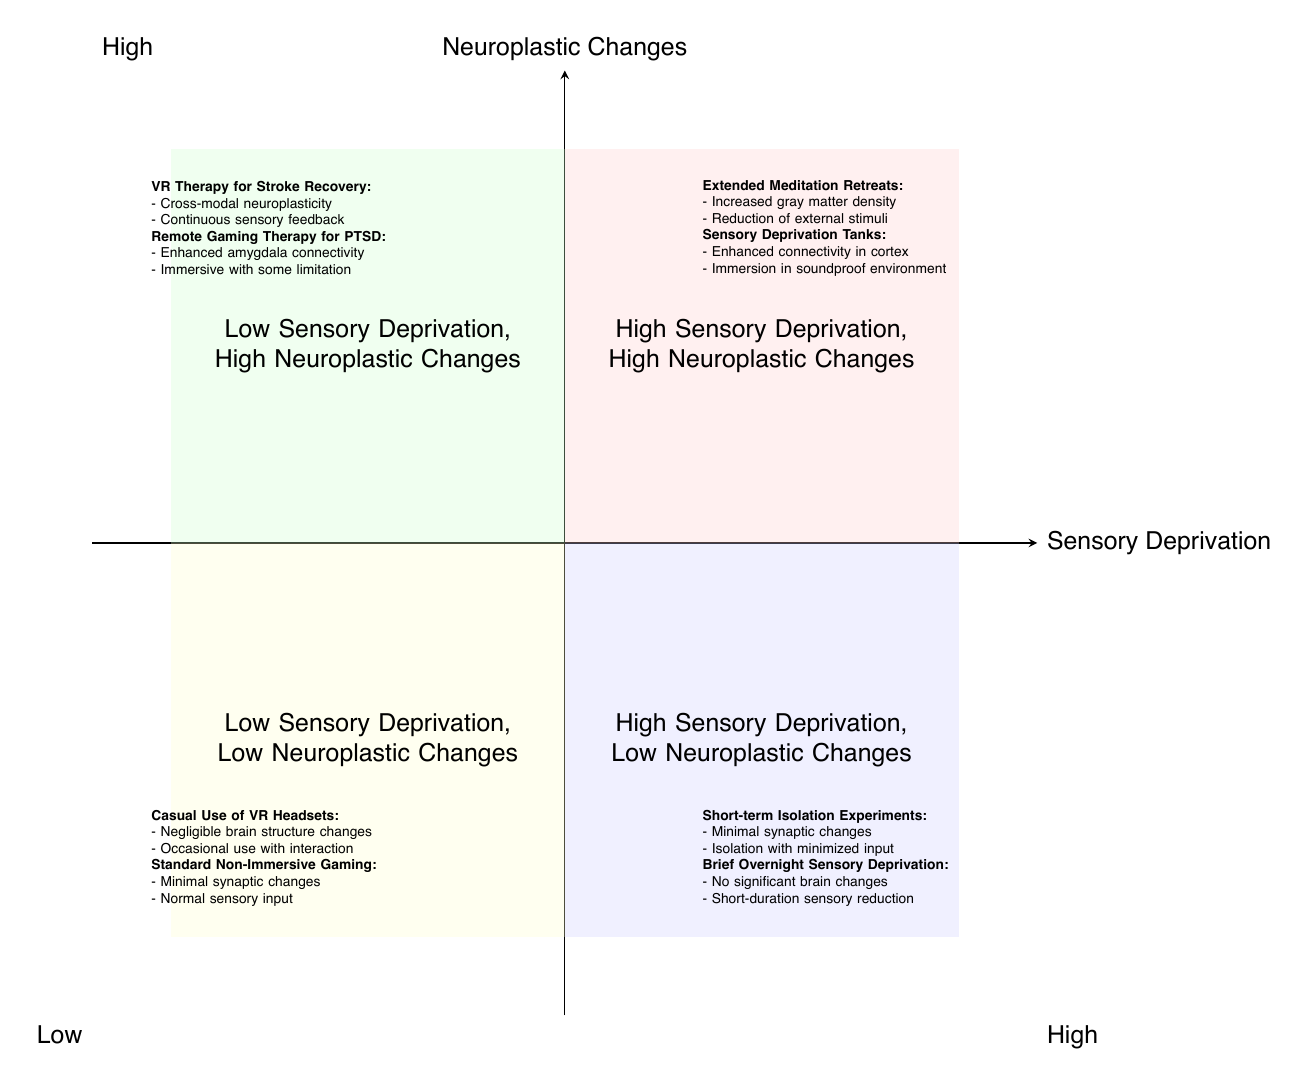What are the two case studies listed in the quadrant for High Sensory Deprivation, High Neuroplastic Changes? The quadrant for High Sensory Deprivation, High Neuroplastic Changes lists "Extended Meditation Retreats" and "Sensory Deprivation Tanks" as its two case studies.
Answer: Extended Meditation Retreats, Sensory Deprivation Tanks Which quadrant is associated with Minimal synaptic changes observed? The quadrant associated with "Minimal synaptic changes observed" is "High Sensory Deprivation, Low Neuroplastic Changes," which includes the case study "Short-term Isolation Experiments."
Answer: High Sensory Deprivation, Low Neuroplastic Changes How many examples are provided for the quadrant "Low Sensory Deprivation, High Neuroplastic Changes"? There are two examples provided in the "Low Sensory Deprivation, High Neuroplastic Changes" quadrant, specifically "Virtual Reality Therapy for Stroke Recovery" and "Remote Gaming Therapy for PTSD."
Answer: 2 What type of neuroplastic changes are observed in "Casual Use of Virtual Reality Headsets"? The neuroplastic changes observed in "Casual Use of Virtual Reality Headsets" are described as "Negligible changes in brain structure."
Answer: Negligible changes in brain structure Which quadrant describes Continuous sensory feedback with minimal deprivation? The quadrant that describes "Continuous sensory feedback with minimal deprivation" is the "Low Sensory Deprivation, High Neuroplastic Changes" quadrant, which includes the case study "Virtual Reality Therapy for Stroke Recovery."
Answer: Low Sensory Deprivation, High Neuroplastic Changes What do the "Extended Meditation Retreats" and "Remote Gaming Therapy for PTSD" have in common? Both "Extended Meditation Retreats" and "Remote Gaming Therapy for PTSD" fall under quadrants that indicate high neuroplastic changes; the former is in the High Sensory Deprivation category and the latter in Low Sensory Deprivation.
Answer: High neuroplastic changes In which quadrant is "Standard Non-Immersive Video Gaming" placed? "Standard Non-Immersive Video Gaming" is placed in the "Low Sensory Deprivation, Low Neuroplastic Changes" quadrant as indicated in the diagram.
Answer: Low Sensory Deprivation, Low Neuroplastic Changes What kind of neuroplastic changes does the case study "Virtual Reality Therapy for Stroke Recovery" show? The neuroplastic changes indicated for the case study "Virtual Reality Therapy for Stroke Recovery" are "Cross-modal neuroplasticity in motor and visual cortices."
Answer: Cross-modal neuroplasticity in motor and visual cortices 